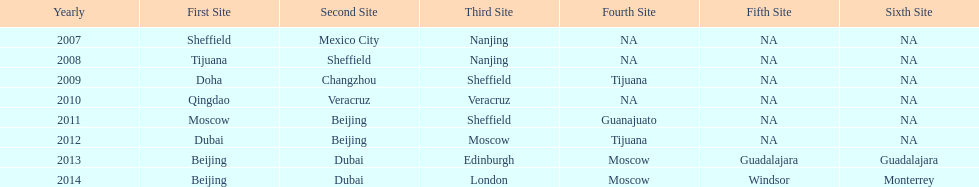In what year was the 3rd venue the same as 2011's 1st venue? 2012. 